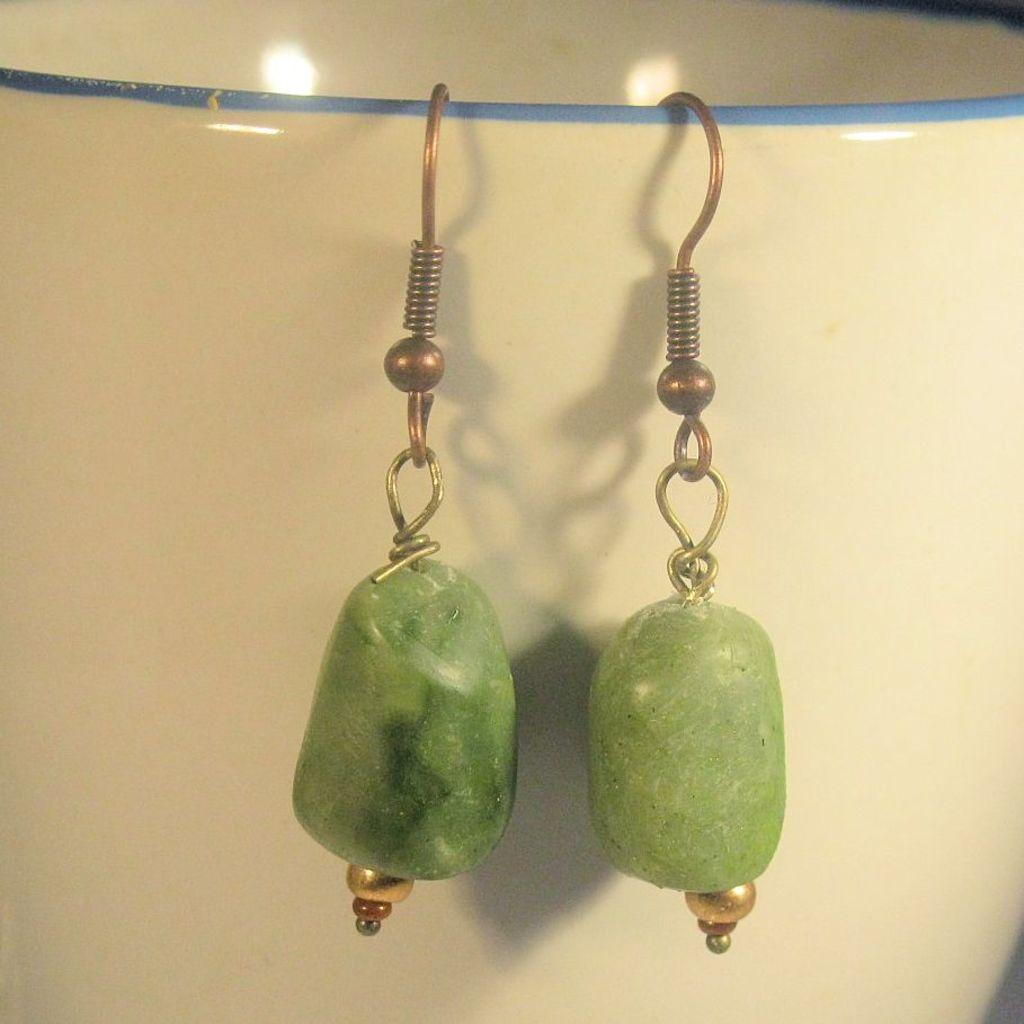What is hanging from the rope in the image? There are earrings hanging from a rope in the image. What can be seen in the background of the image? There is a wall in the image. What type of rhythm can be heard coming from the earrings in the image? There is no sound or rhythm associated with the earrings in the image. 